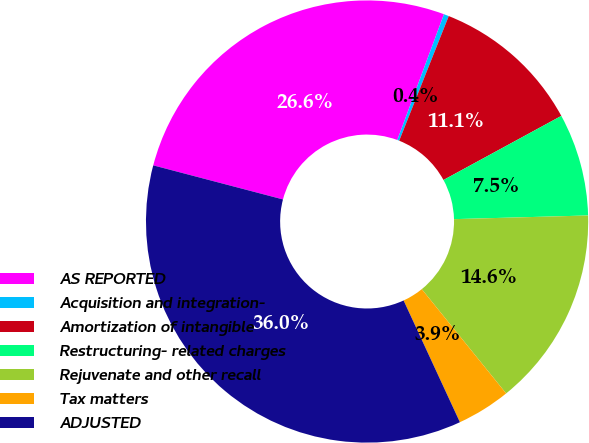Convert chart. <chart><loc_0><loc_0><loc_500><loc_500><pie_chart><fcel>AS REPORTED<fcel>Acquisition and integration-<fcel>Amortization of intangible<fcel>Restructuring- related charges<fcel>Rejuvenate and other recall<fcel>Tax matters<fcel>ADJUSTED<nl><fcel>26.56%<fcel>0.37%<fcel>11.05%<fcel>7.49%<fcel>14.61%<fcel>3.93%<fcel>35.98%<nl></chart> 